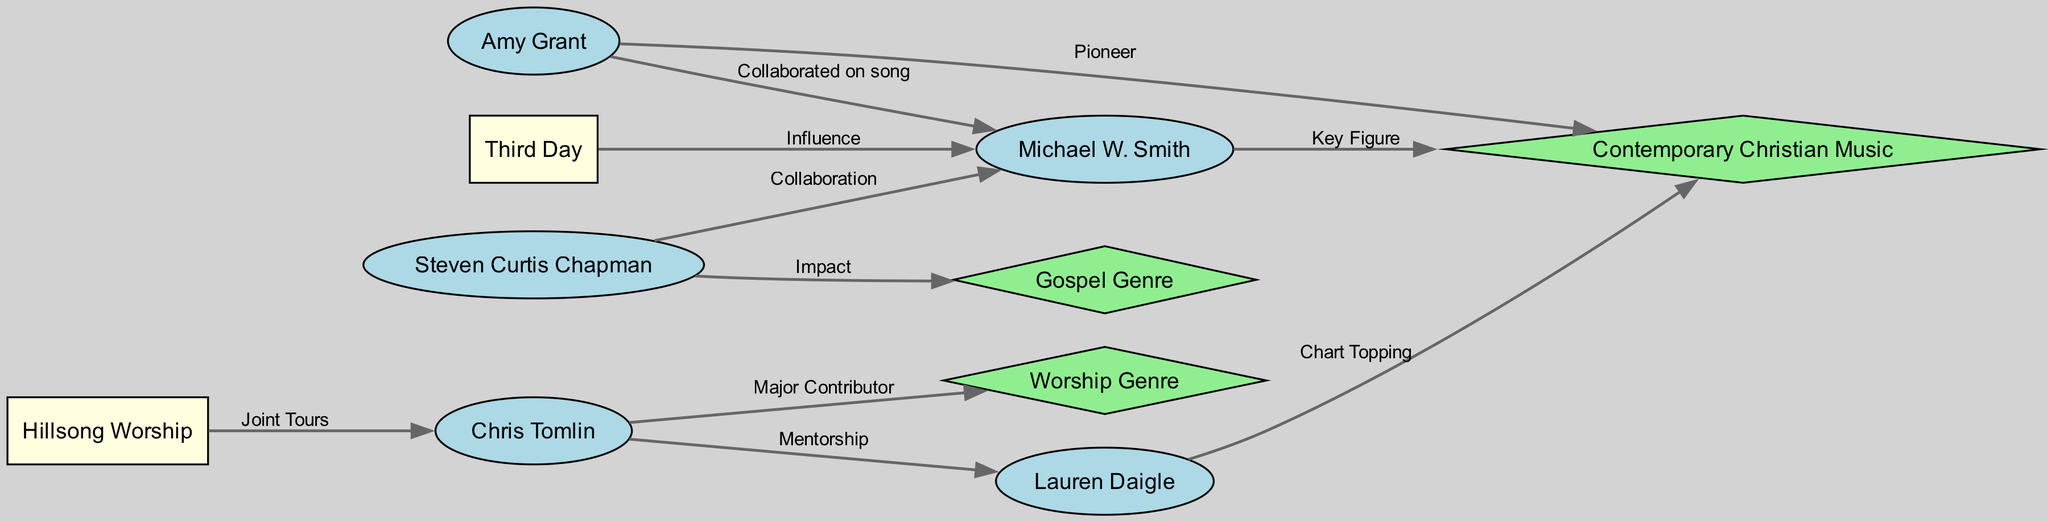What is the total number of musicians in the diagram? There are six musicians listed within the nodes: Amy Grant, Michael W. Smith, Chris Tomlin, Steven Curtis Chapman, Lauren Daigle, and Third Day. Counting these nodes gives a total of 6 musicians.
Answer: 6 Who did Lauren Daigle receive mentorship from? According to the edge connecting Chris Tomlin to Lauren Daigle, this arrow indicates a mentorship relationship. Therefore, Lauren Daigle's mentor is Chris Tomlin.
Answer: Chris Tomlin How many edges are present in the diagram? The diagram contains nine edges connecting various nodes. Each edge represents a type of relationship or influence among the nodes. Counting these edges gives a total of 9.
Answer: 9 Which genre is associated with Chris Tomlin? The edge directed from Chris Tomlin to Worship Genre indicates his significant contribution to this music genre. Thus, the Worship Genre is associated with Chris Tomlin.
Answer: Worship Genre Who is described as a "Pioneer" in the context of the Contemporary Christian Music genre? The arrow from Amy Grant to the Contemporary Christian Music node labels her as a "Pioneer." This indicates her foundational role in this genre. Thus, Amy Grant is identified as the "Pioneer".
Answer: Amy Grant What type of relationship exists between Hillsong Worship and Chris Tomlin? The diagram specifies a "Joint Tours" relationship between Hillsong Worship and Chris Tomlin. This means they have collaborated for tours, indicating a musical partnership.
Answer: Joint Tours Explain the impact Steven Curtis Chapman has on the Gospel Genre. The diagram shows an edge from Steven Curtis Chapman to Gospel Genre, labeled "Impact". This indicates that his work has significantly influenced and shaped the Gospel Genre. Therefore, the relationship reveals his contribution as an impactful figure within this genre.
Answer: Impact Which musician is identified as a "Key Figure" in Contemporary Christian Music? The connection from Michael W. Smith to the Contemporary Christian Music node labels him a "Key Figure." This indicates his significant role and influence within this genre. Hence, Michael W. Smith is the musician described as a "Key Figure".
Answer: Michael W. Smith 